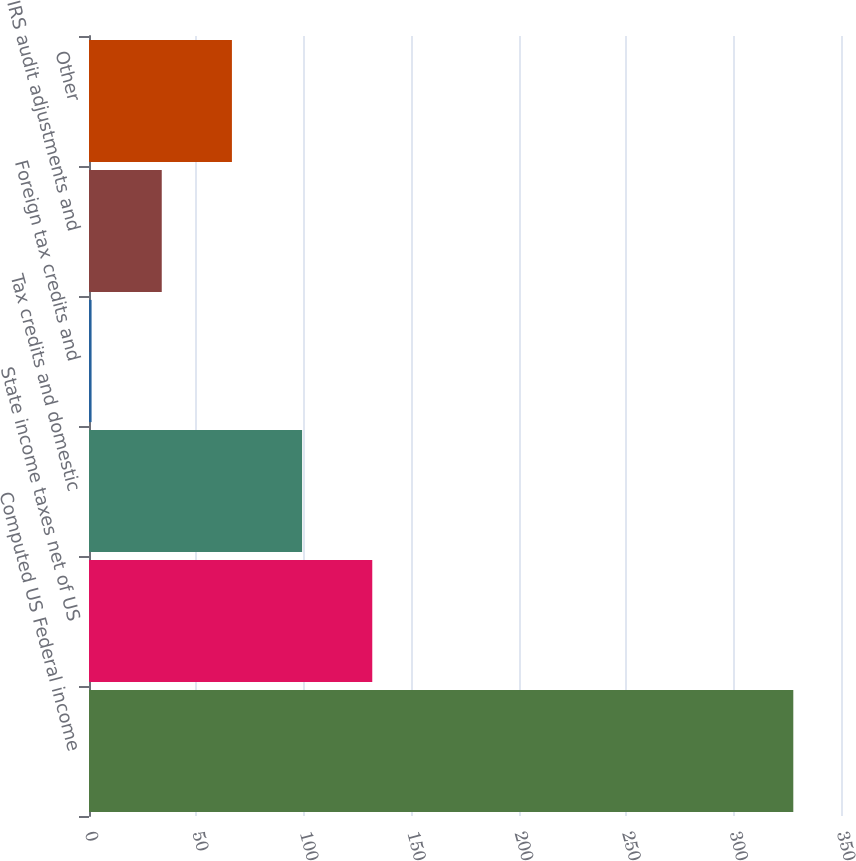<chart> <loc_0><loc_0><loc_500><loc_500><bar_chart><fcel>Computed US Federal income<fcel>State income taxes net of US<fcel>Tax credits and domestic<fcel>Foreign tax credits and<fcel>IRS audit adjustments and<fcel>Other<nl><fcel>327.8<fcel>131.84<fcel>99.18<fcel>1.2<fcel>33.86<fcel>66.52<nl></chart> 